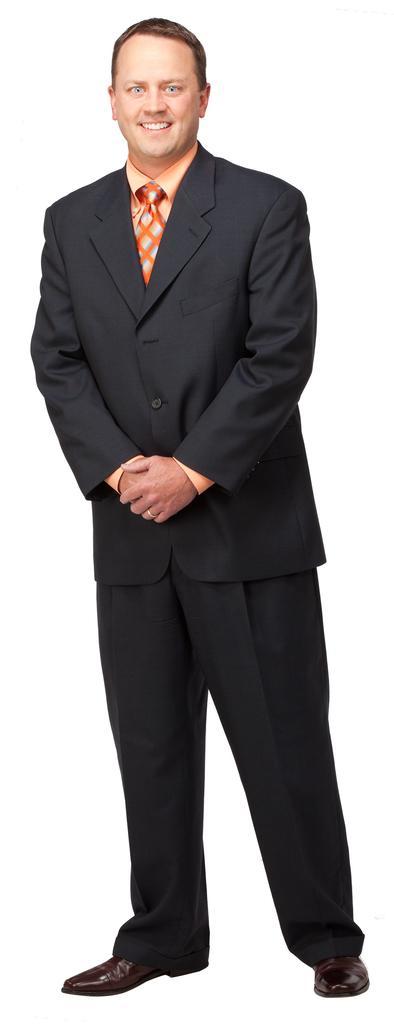Describe this image in one or two sentences. In this picture we can see a person, he is smiling and in the background we can it is white color. 